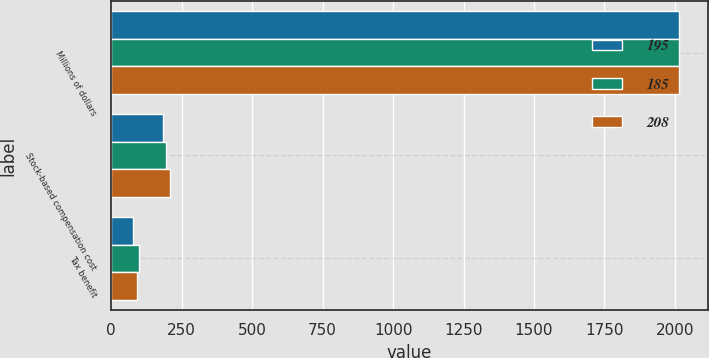Convert chart to OTSL. <chart><loc_0><loc_0><loc_500><loc_500><stacked_bar_chart><ecel><fcel>Millions of dollars<fcel>Stock-based compensation cost<fcel>Tax benefit<nl><fcel>195<fcel>2016<fcel>185<fcel>77<nl><fcel>185<fcel>2015<fcel>195<fcel>99<nl><fcel>208<fcel>2014<fcel>208<fcel>90<nl></chart> 